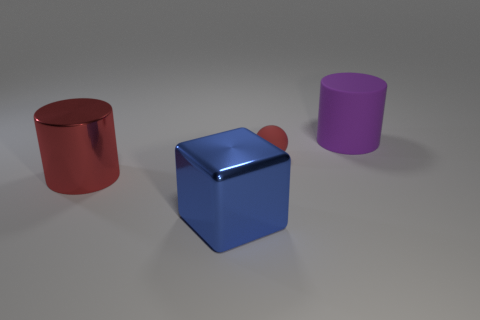There is a cylinder that is on the left side of the thing in front of the large cylinder left of the tiny red object; what is it made of?
Keep it short and to the point. Metal. Is the large blue cube made of the same material as the red thing right of the red metallic thing?
Offer a terse response. No. Are there fewer purple objects to the left of the blue metal cube than red objects that are in front of the small object?
Give a very brief answer. Yes. How many blue things are the same material as the large blue block?
Keep it short and to the point. 0. Are there any red metallic cylinders that are on the right side of the large cylinder that is behind the cylinder that is in front of the matte cylinder?
Ensure brevity in your answer.  No. How many cubes are purple matte things or large red things?
Provide a short and direct response. 0. There is a small red thing; is it the same shape as the red thing on the left side of the blue object?
Give a very brief answer. No. Are there fewer big cylinders that are in front of the large matte object than big red metal things?
Offer a terse response. No. Are there any blue metal objects in front of the big blue shiny object?
Offer a terse response. No. Are there any other large metal things of the same shape as the large red metal object?
Keep it short and to the point. No. 